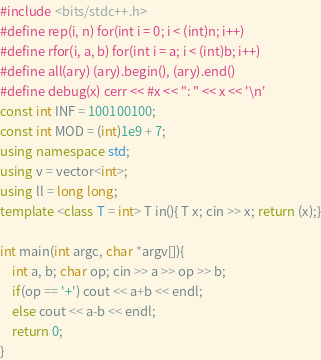Convert code to text. <code><loc_0><loc_0><loc_500><loc_500><_C++_>#include <bits/stdc++.h>
#define rep(i, n) for(int i = 0; i < (int)n; i++)
#define rfor(i, a, b) for(int i = a; i < (int)b; i++)
#define all(ary) (ary).begin(), (ary).end()
#define debug(x) cerr << #x << ": " << x << '\n'
const int INF = 100100100;
const int MOD = (int)1e9 + 7;
using namespace std;
using v = vector<int>;
using ll = long long;
template <class T = int> T in(){ T x; cin >> x; return (x);}

int main(int argc, char *argv[]){
    int a, b; char op; cin >> a >> op >> b;
    if(op == '+') cout << a+b << endl;
    else cout << a-b << endl;
    return 0;
}</code> 